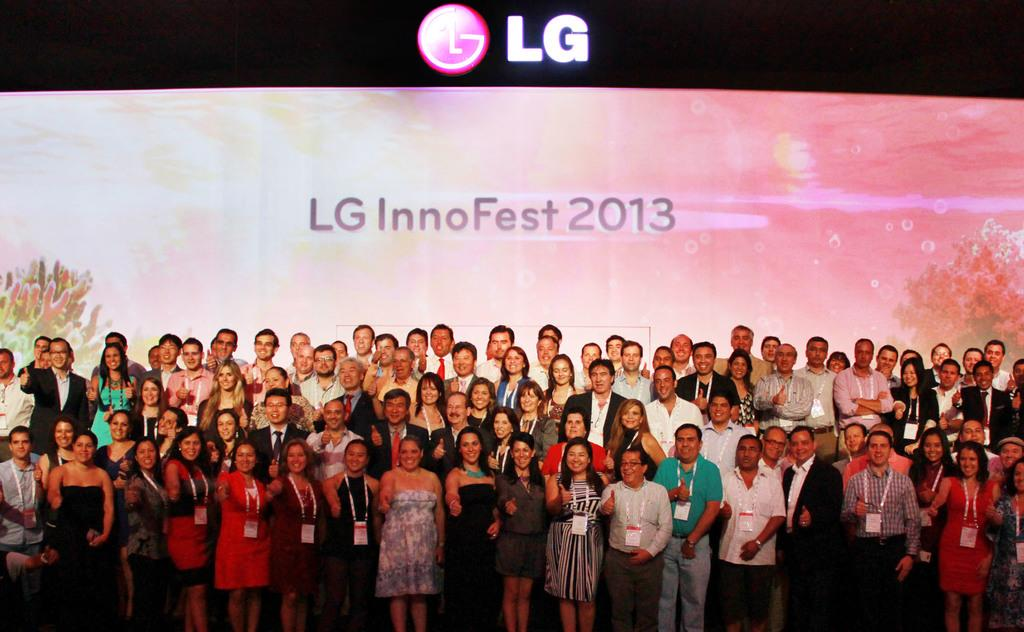What can be seen at the bottom of the image? There are people standing at the bottom of the image. What is present in the background of the image? There is a screen visible in the background of the image. What type of voice can be heard coming from the screen in the image? There is no information about any voice or sound in the image, as it only shows people standing at the bottom and a screen in the background. 